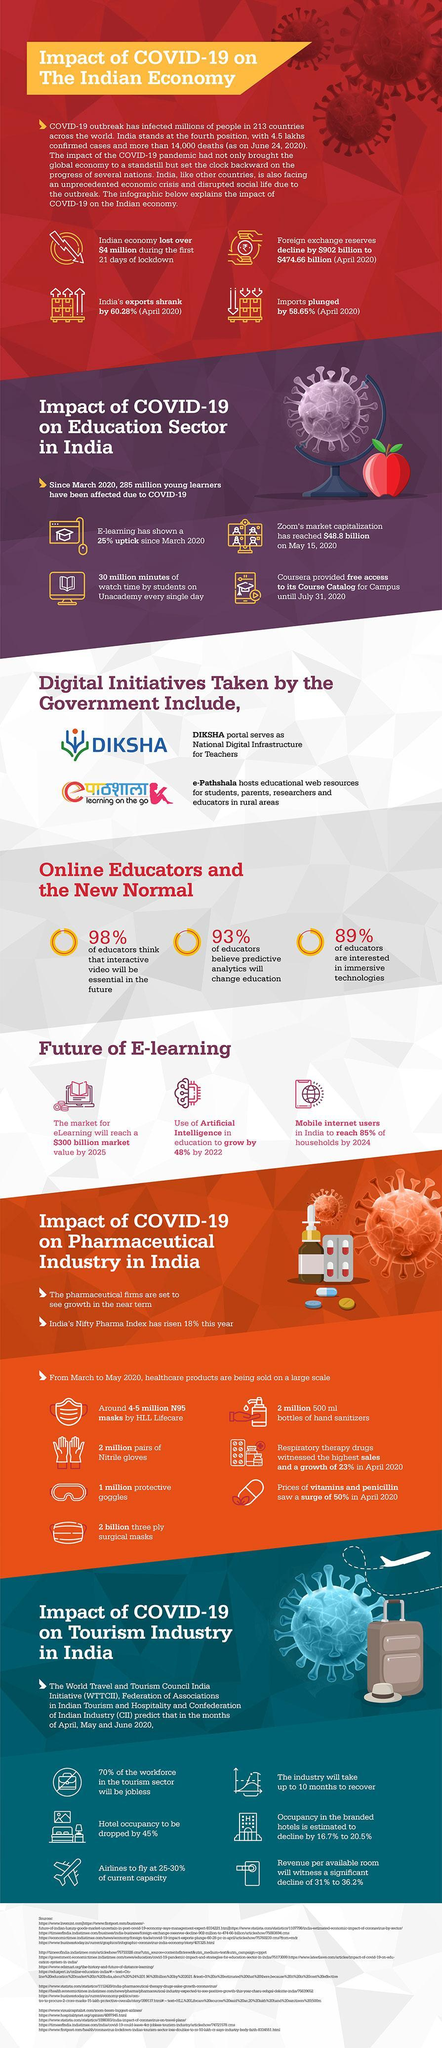What is the percentage of decrease in Indian exports?
Answer the question with a short phrase. 60.28% What percentage of educators are interested in immersive technologies? 89% How many half litre bottles of sanitizers where made? 2 million How much time is tourism industry expect to take to recoup? 10 months What was the decrease in the foreign exchange reserves of India in April($bn)? 427.34 What percent of employees in the tourism industry, will lose their jobs? 70% By how much is the 'use of of artificial intelligence in education' expected to increase? 48% Which are the two initiatives taken up by the Indian government in the field of education? DIKSHA, e-Pathshala How many masks where made by HLL Lifecare? 4-5 million What percentage of educators considered interactive videos to be a necessity in the future? 98% How much is the revenue per room in hotels expected to decrease? 31% to 36.2% Which online learning platform provides free access to its courses? Coursera What is the percentage of decrease in Indian imports? 58.65% What was the economic loss incurred by India during the initial 3 weeks of lockdown? $4 million Which video conferencing company crossed  $45 billion market cap? Zoom Which online learning platform has a daily watch time of 30 million minutes? Unacademy 